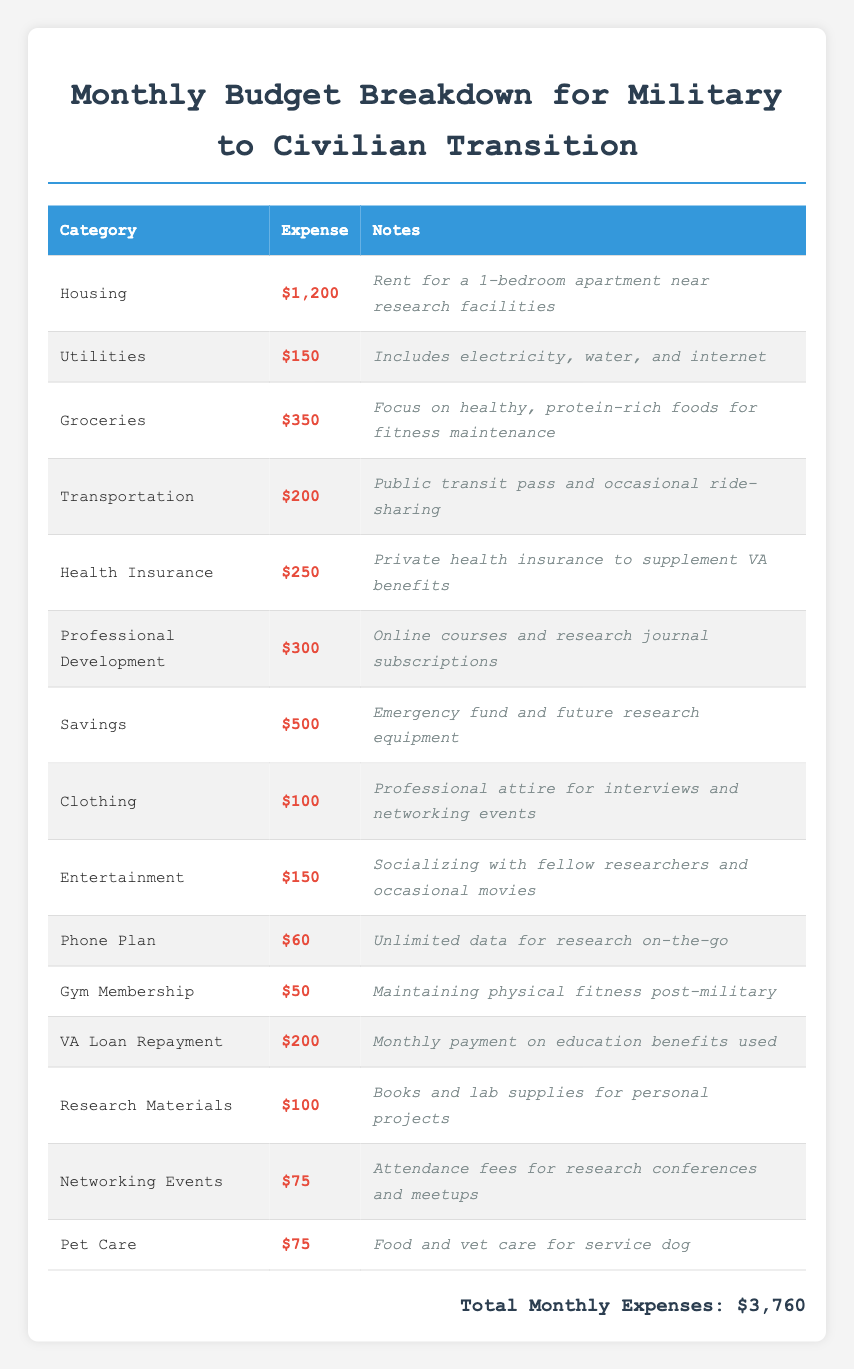What is the total budget required for housing expenses? The table lists that Housing expenses are $1,200. Since this is the only entry under the housing category, the total is simply the value shown.
Answer: 1200 What is the total expense for groceries and health insurance combined? To find the combined total, we need to add the Groceries expense, which is $350, and the Health Insurance expense, which is $250. Therefore, the total is $350 + $250 = $600.
Answer: 600 Is the expense for professional development greater than the combined expense for entertainment and clothing? The Professional Development expense is $300. The combined expense for Entertainment ($150) and Clothing ($100) is $250. Since $300 is greater than $250, the answer is yes.
Answer: Yes How much is spent on transportation compared to utility expenses? The Transportation expense is $200 while the Utilities expense is $150. To compare, we notice that $200 is greater than $150, indicating a higher expenditure on transportation.
Answer: Transportation is greater What is the total expenditure on gym membership and phone plan combined? The Gym Membership costs $50 and the Phone Plan costs $60. Adding these two amounts gives us $50 + $60 = $110. Thus, the total expenditure for gym membership and phone plan combined is $110.
Answer: 110 What is the total amount spent on savings, networking events, and research materials? The individual expenses are Savings at $500, Networking Events at $75, and Research Materials at $100. Adding them together gives us $500 + $75 + $100 = $675.
Answer: 675 Are the total monthly expenses below $4,000? The total monthly expenses listed are $3,760. Since this value is less than $4,000, the answer is yes.
Answer: Yes What is the average expense per category given there are 14 categories total? The total monthly expenses are $3,760 and there are 14 categories. To find the average, we divide the total by the number of categories: $3,760 / 14 = approximately $268.57.
Answer: 268.57 How much more is spent on health insurance than on gym membership? The Health Insurance expense is $250, and the Gym Membership expense is $50. To find the difference, we subtract: $250 - $50 = $200. Thus, there is a difference of $200 more spent on health insurance.
Answer: 200 